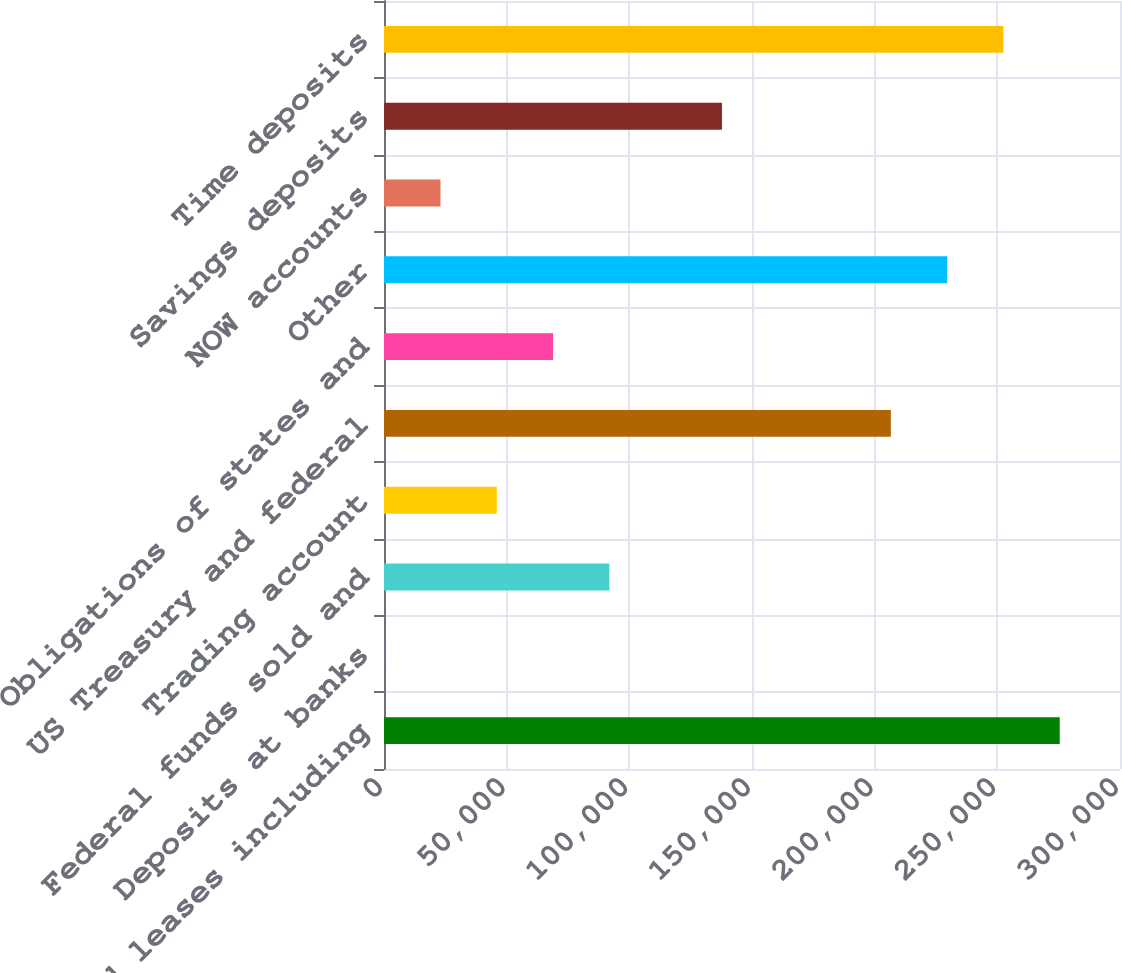<chart> <loc_0><loc_0><loc_500><loc_500><bar_chart><fcel>Loans and leases including<fcel>Deposits at banks<fcel>Federal funds sold and<fcel>Trading account<fcel>US Treasury and federal<fcel>Obligations of states and<fcel>Other<fcel>NOW accounts<fcel>Savings deposits<fcel>Time deposits<nl><fcel>275437<fcel>71<fcel>91859.8<fcel>45965.4<fcel>206596<fcel>68912.6<fcel>229543<fcel>23018.2<fcel>137754<fcel>252490<nl></chart> 